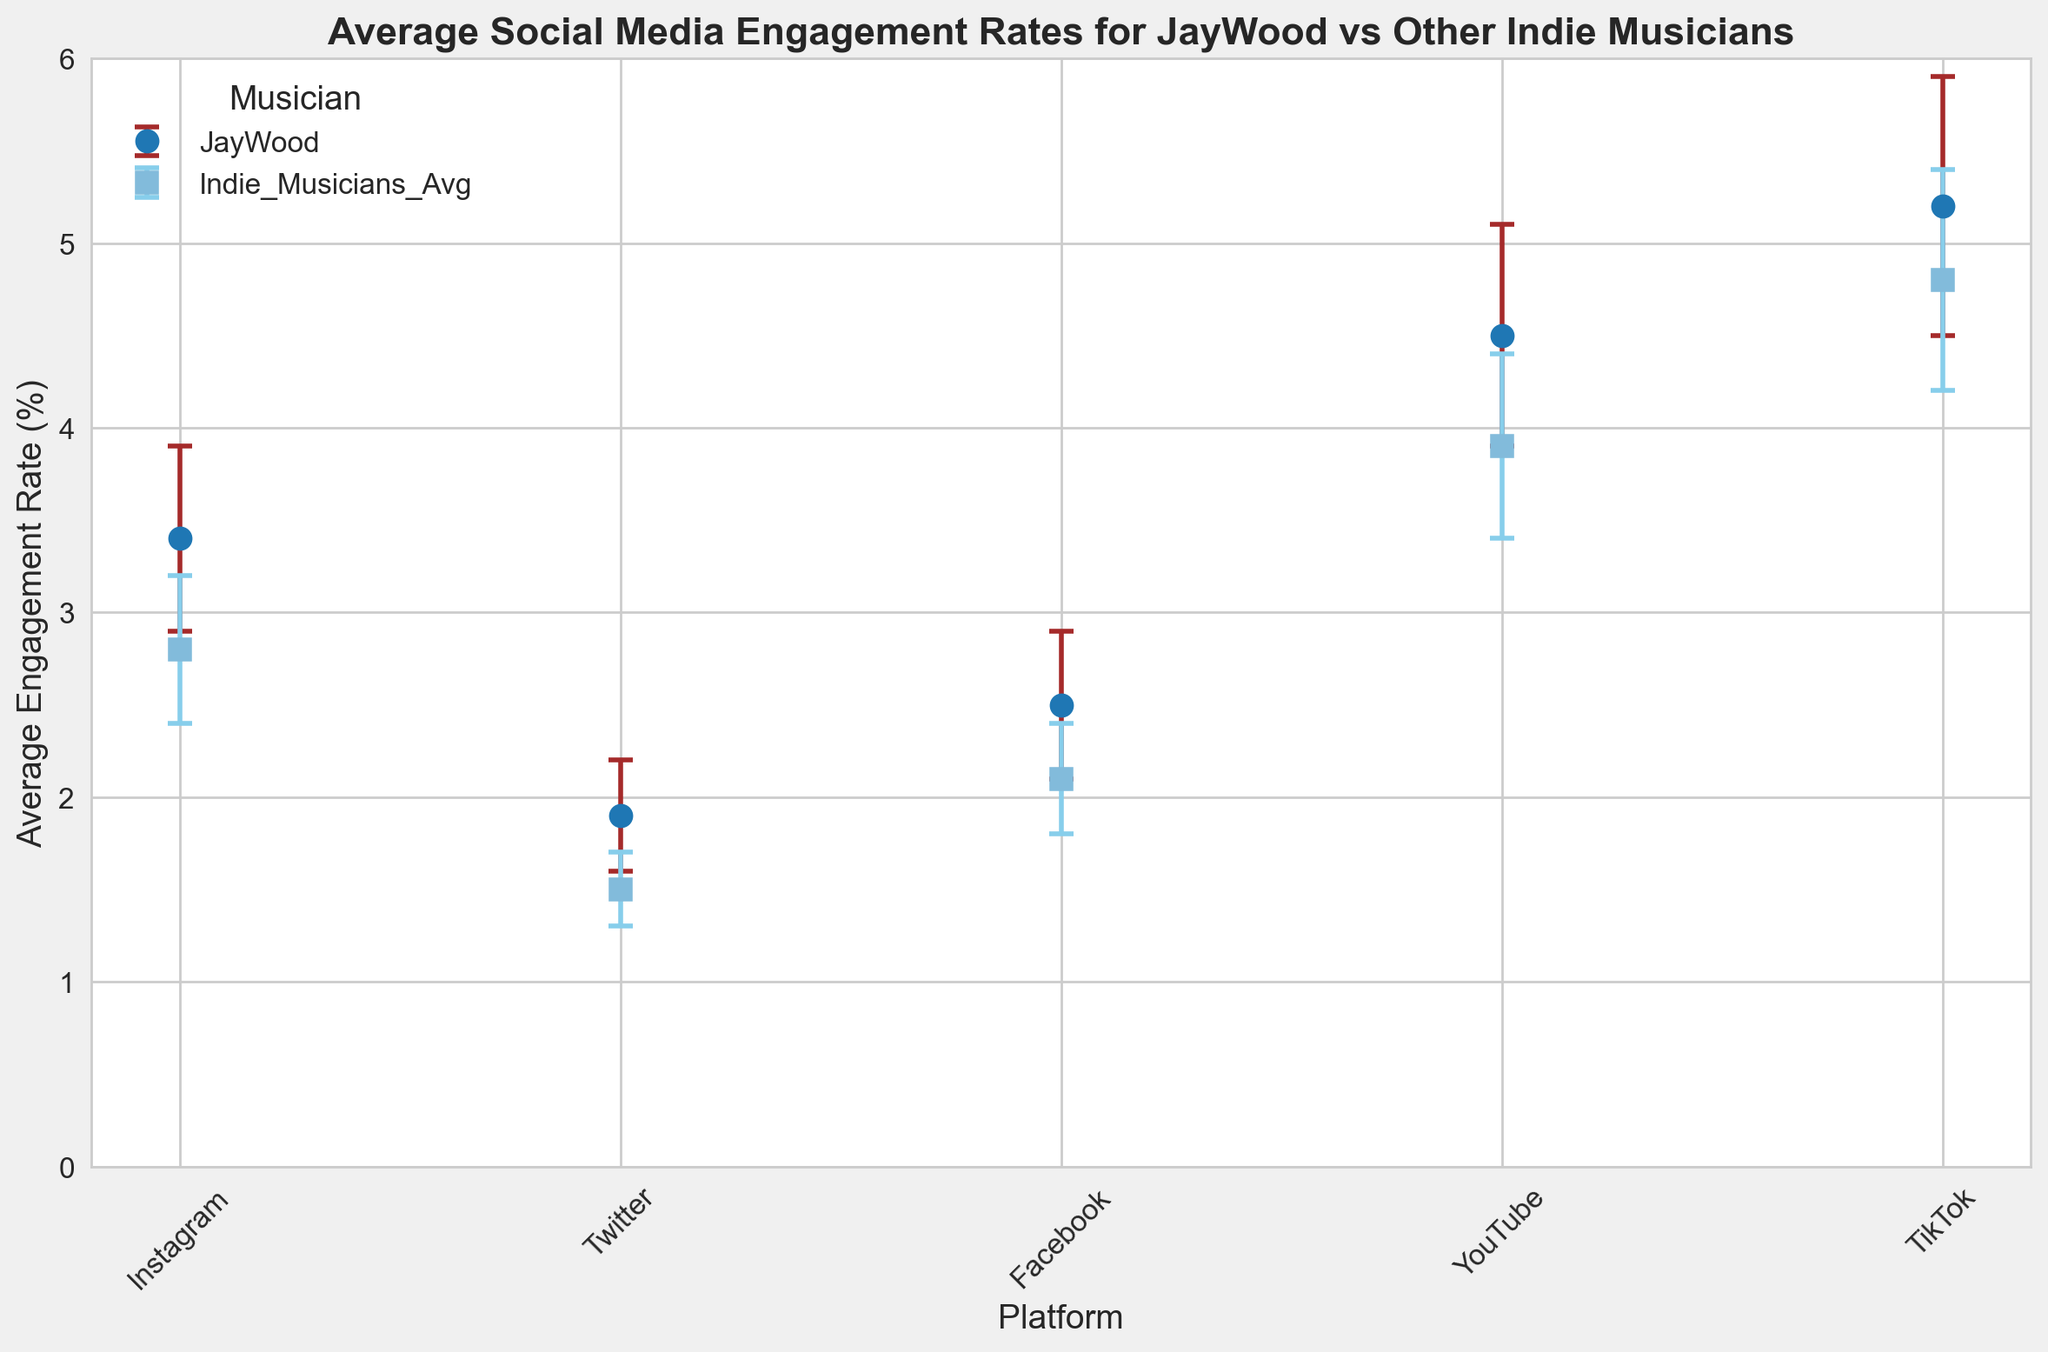Which platform has the highest average engagement rate for JayWood? By looking at the heights of the markers for JayWood across all platforms, the tallest marker represents the highest average engagement rate. JayWood's TikTok engagement rate is the highest at 5.2%.
Answer: TikTok Which platform shows the smallest error margin for Indie Musicians' Average? To find the smallest error margin for Indie Musicians' Average, compare the error bars for Indie Musicians' Average across all platforms. The shortest error bar corresponds to Twitter with an error margin of 0.2.
Answer: Twitter Which platform has the largest difference in average engagement rate between JayWood and Indie Musicians' Average? Calculate the difference in engagement rates between JayWood and Indie Musicians' Average for each platform and compare. The differences are: Instagram (3.4 - 2.8 = 0.6), Twitter (1.9 - 1.5 = 0.4), Facebook (2.5 - 2.1 = 0.4), YouTube (4.5 - 3.9 = 0.6), TikTok (5.2 - 4.8 = 0.4). Both Instagram and YouTube have the largest difference of 0.6.
Answer: Instagram and YouTube What is the sum of the average engagement rates for JayWood across all platforms? Add the average engagement rates for JayWood across different platforms: 3.4 (Instagram) + 1.9 (Twitter) + 2.5 (Facebook) + 4.5 (YouTube) + 5.2 (TikTok) = 17.5.
Answer: 17.5 Is JayWood's engagement rate on Facebook higher than the error margin for Indie Musicians' Average on TikTok? JayWood's engagement rate on Facebook is 2.5. The error margin for Indie Musicians' Average on TikTok is 0.6. Compare the two values: 2.5 > 0.6.
Answer: Yes What is the average engagement rate of Indie Musicians on YouTube and TikTok combined? Calculate the average of the given engagement rates: (3.9 (YouTube) + 4.8 (TikTok)) / 2 = 4.35.
Answer: 4.35 On which platform is the difference between error margins for JayWood and Indie Musicians' Average the greatest? Calculate the difference in error margins for each platform: Instagram (0.5 - 0.4 = 0.1), Twitter (0.3 - 0.2 = 0.1), Facebook (0.4 - 0.3 = 0.1), YouTube (0.6 - 0.5 = 0.1), TikTok (0.7 - 0.6 = 0.1). All differences are equal at 0.1.
Answer: All platforms Are there any platforms where JayWood's average engagement rate is equal to the average engagement rate of Indie Musicians? Compare JayWood's engagement rates with those of Indie Musicians across all platforms. There is no platform where the rates match exactly.
Answer: No What is the total error margin for JayWood across all platforms combined? Sum the error margins for JayWood across all platforms: 0.5 (Instagram) + 0.3 (Twitter) + 0.4 (Facebook) + 0.6 (YouTube) + 0.7 (TikTok) = 2.5.
Answer: 2.5 